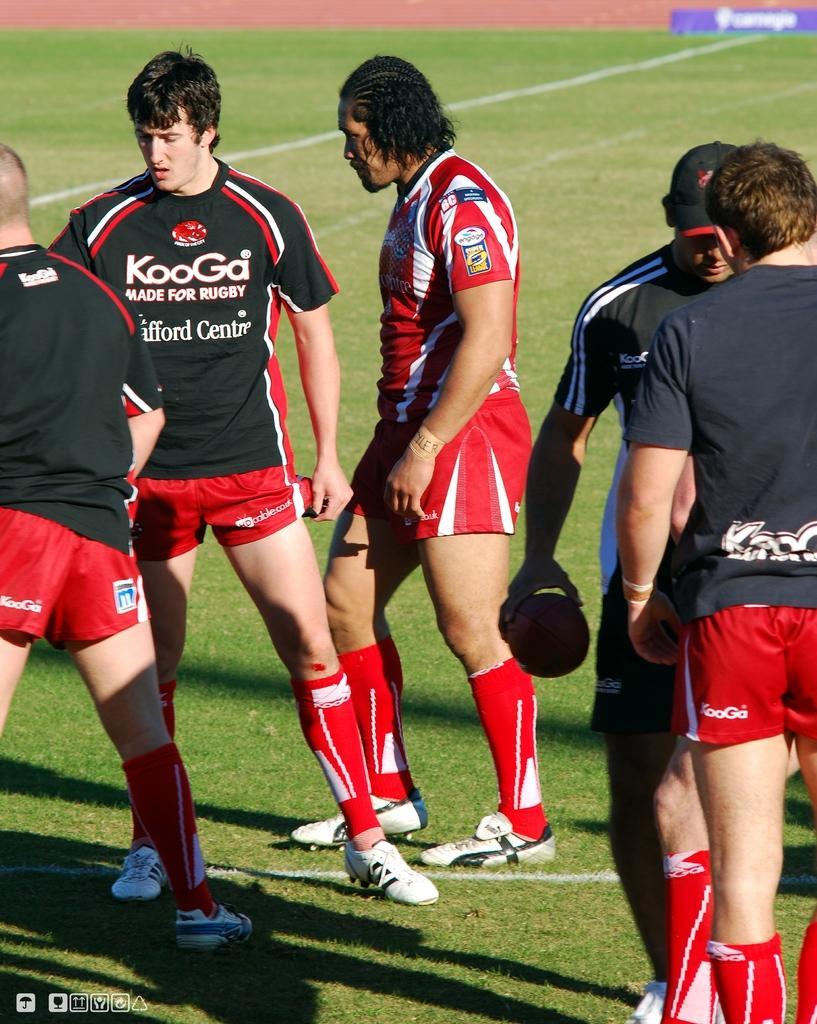Please provide a concise description of this image. There are players. Some of them are in black color t-shirts and one person in red color t-shirt on the grass on the ground. In front of them, there is watermark. In the background, there are two white color lines on the grass on the ground and there is dry land. 